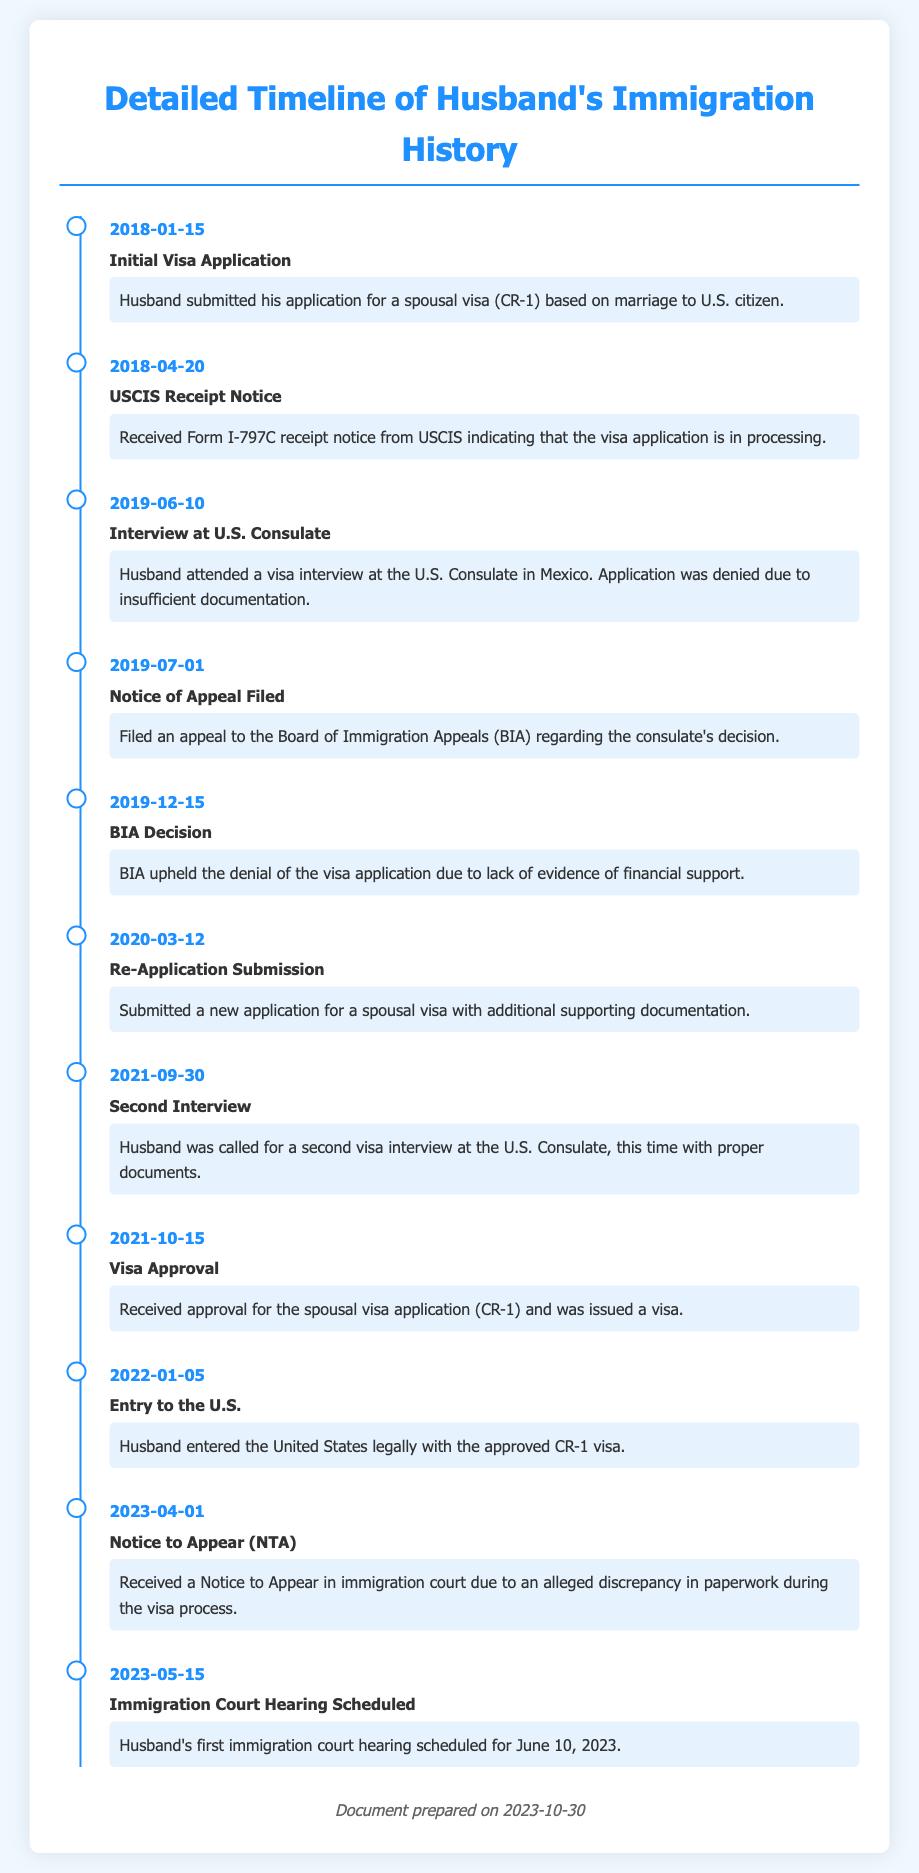What was the date of the initial visa application? The initial visa application was submitted on January 15, 2018.
Answer: 2018-01-15 What notice did the husband receive on April 20, 2018? On April 20, 2018, the husband received a Form I-797C receipt notice from USCIS.
Answer: USCIS Receipt Notice What was the outcome of the first visa interview on June 10, 2019? The visa application was denied due to insufficient documentation during the first visa interview.
Answer: Denied When was the BIA decision made regarding the appeal? The BIA decision was made on December 15, 2019.
Answer: 2019-12-15 When did the husband enter the United States? The husband entered the United States legally on January 5, 2022.
Answer: 2022-01-05 What type of notice was received on April 1, 2023? The notice received was a Notice to Appear in immigration court.
Answer: Notice to Appear How many times did the husband attend a visa interview? The husband attended two visa interviews.
Answer: Two What significant event occurred on October 15, 2021? On October 15, 2021, the husband received approval for the spousal visa application.
Answer: Visa Approval What is the scheduled date for the first immigration court hearing? The first immigration court hearing is scheduled for June 10, 2023.
Answer: June 10, 2023 